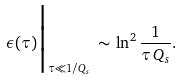<formula> <loc_0><loc_0><loc_500><loc_500>\epsilon ( \tau ) \Big | _ { \tau \ll 1 / Q _ { s } } \, \sim \, \ln ^ { 2 } \frac { 1 } { \tau \, Q _ { s } } .</formula> 